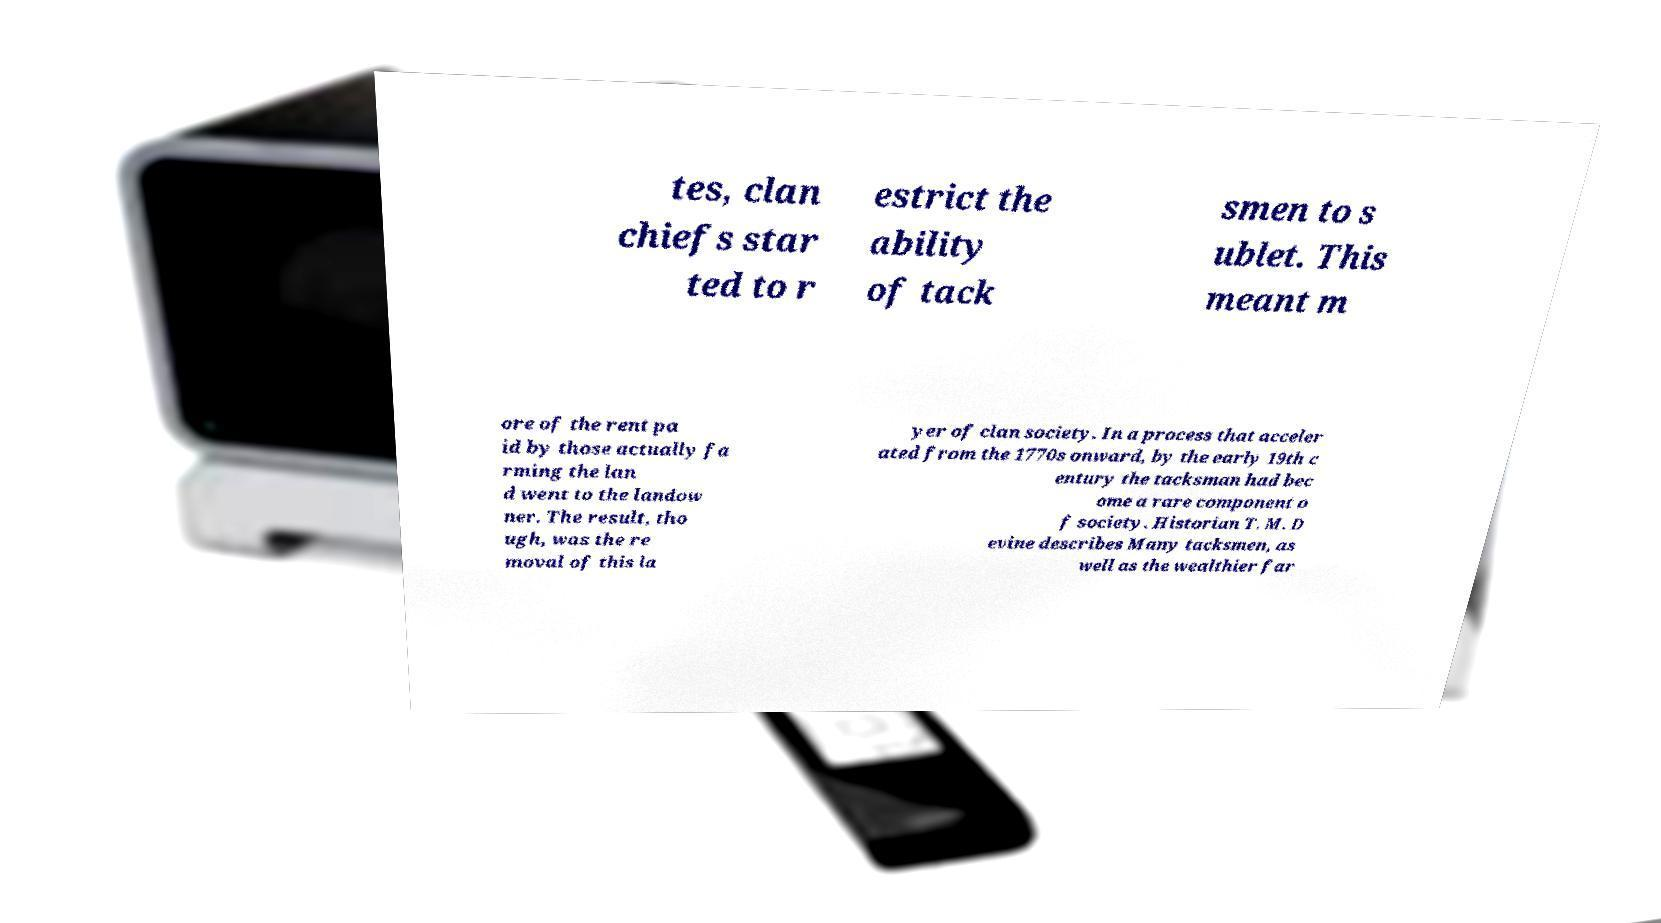Can you accurately transcribe the text from the provided image for me? tes, clan chiefs star ted to r estrict the ability of tack smen to s ublet. This meant m ore of the rent pa id by those actually fa rming the lan d went to the landow ner. The result, tho ugh, was the re moval of this la yer of clan society. In a process that acceler ated from the 1770s onward, by the early 19th c entury the tacksman had bec ome a rare component o f society. Historian T. M. D evine describes Many tacksmen, as well as the wealthier far 